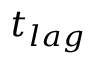Convert formula to latex. <formula><loc_0><loc_0><loc_500><loc_500>t _ { l a g }</formula> 